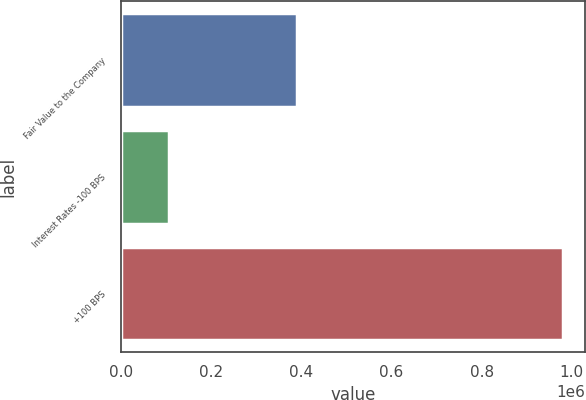Convert chart. <chart><loc_0><loc_0><loc_500><loc_500><bar_chart><fcel>Fair Value to the Company<fcel>Interest Rates -100 BPS<fcel>+100 BPS<nl><fcel>389572<fcel>106444<fcel>980694<nl></chart> 